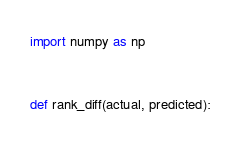<code> <loc_0><loc_0><loc_500><loc_500><_Python_>import numpy as np


def rank_diff(actual, predicted):</code> 